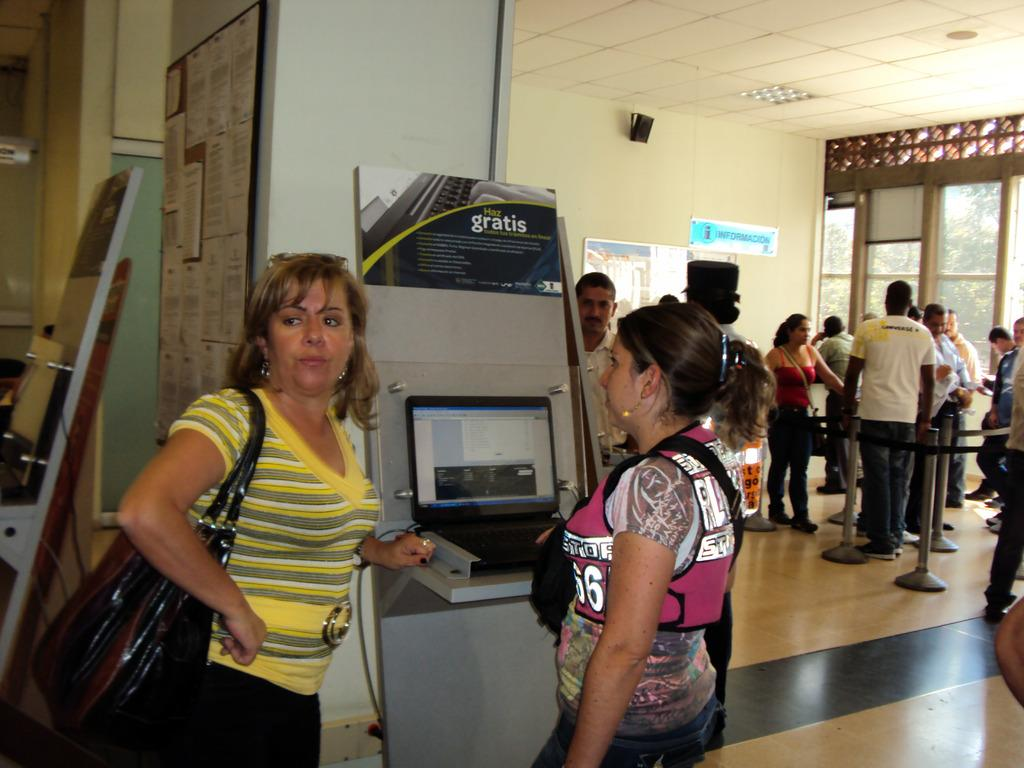<image>
Give a short and clear explanation of the subsequent image. A blue information sign can be seen on a wall. 